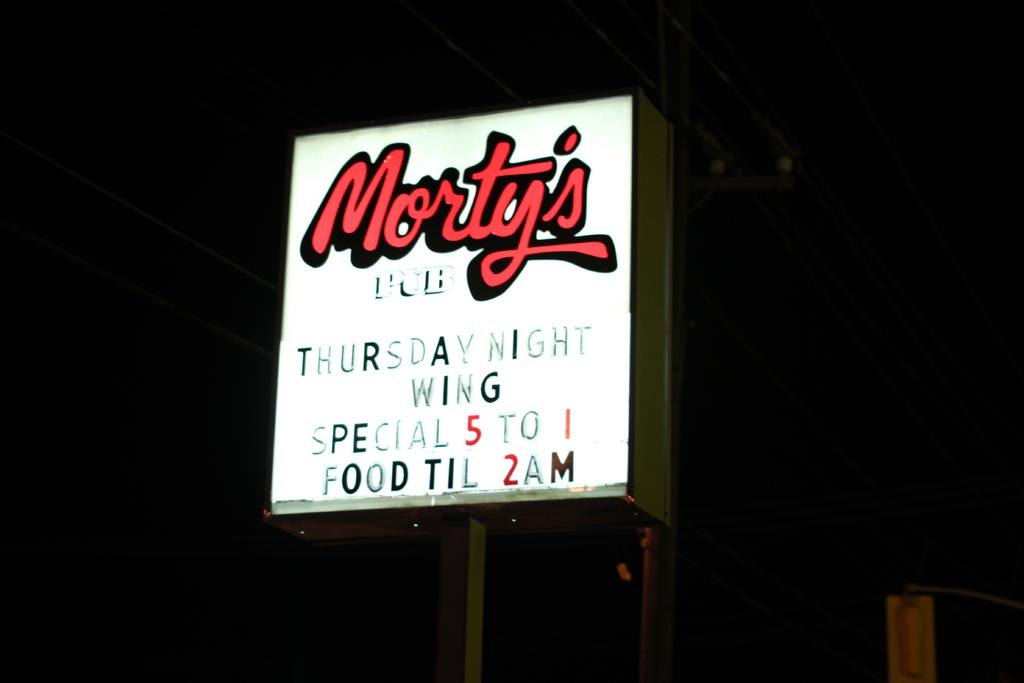<image>
Describe the image concisely. Morty's thursday night wing special on a banner outside 